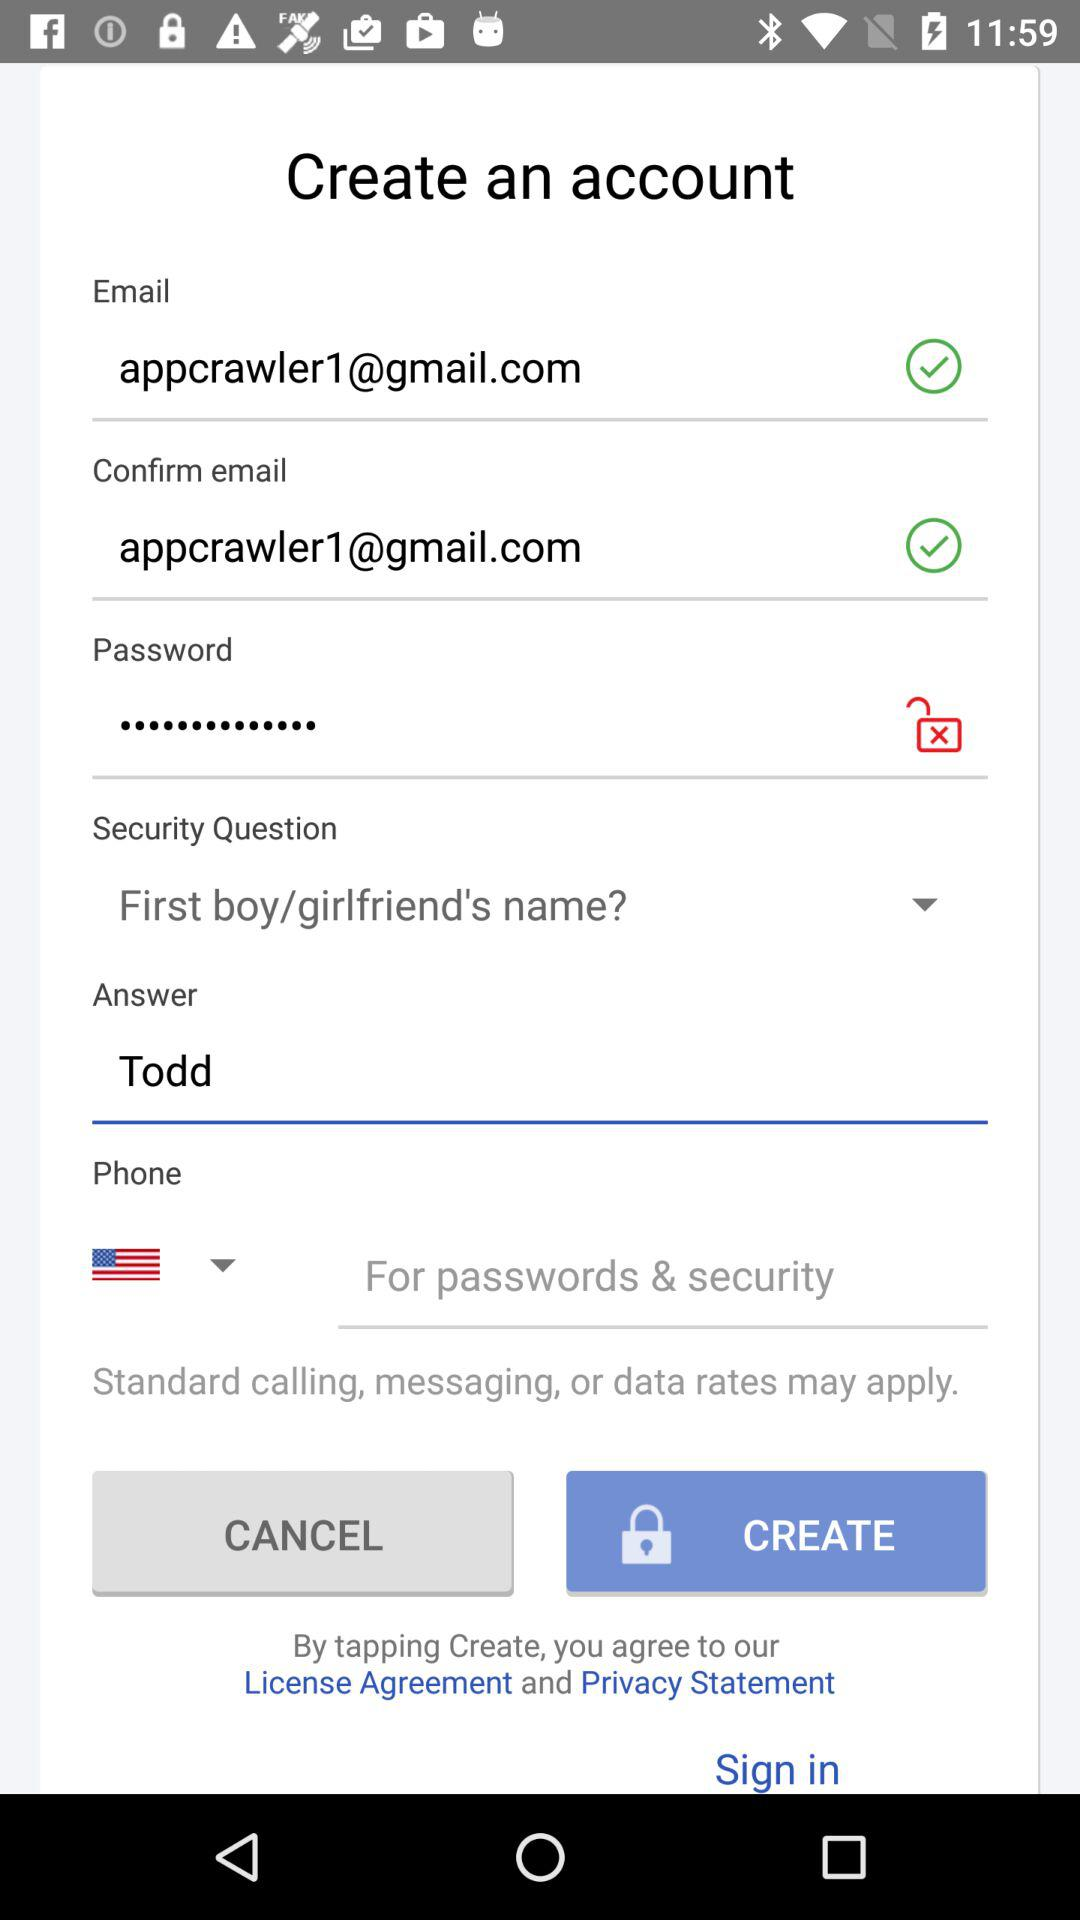What is the security question? The security question is "First boy/girlfriend's name?". 